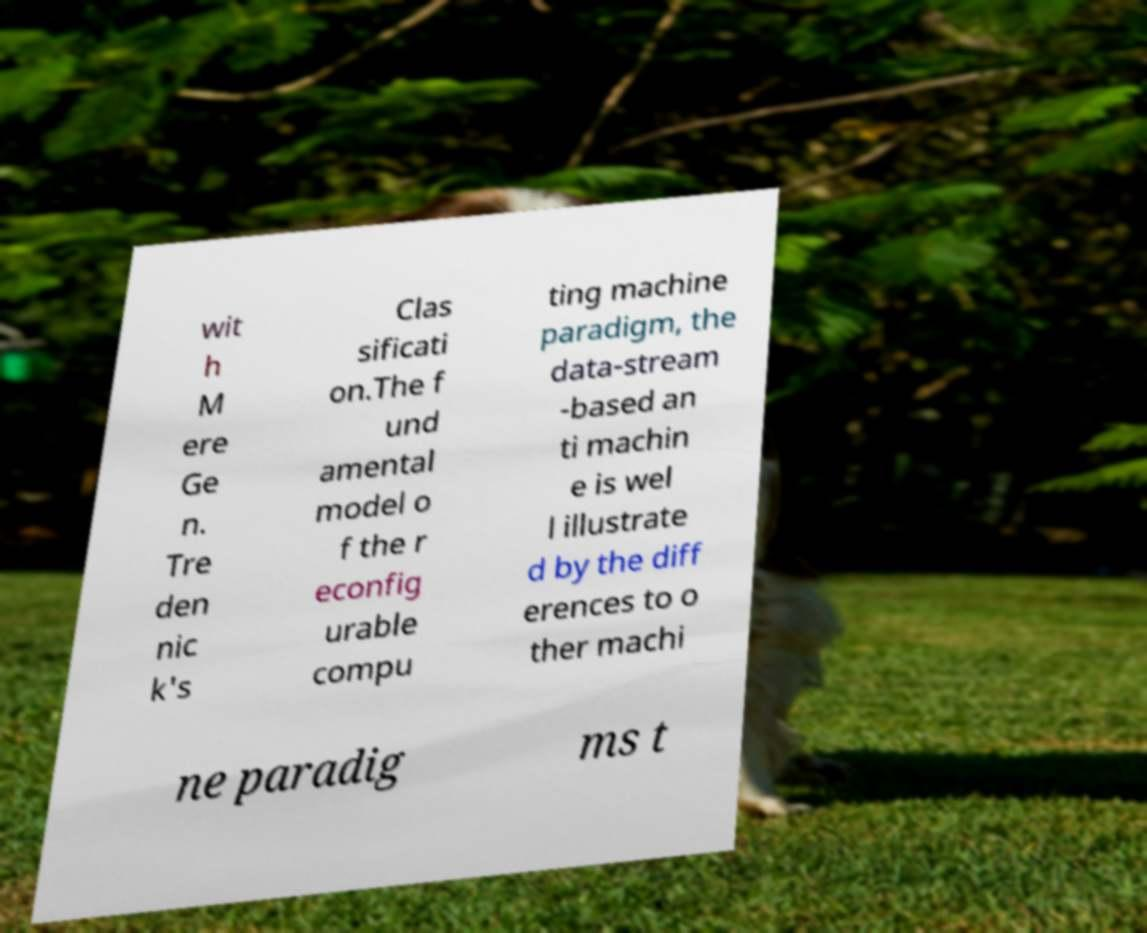Please read and relay the text visible in this image. What does it say? wit h M ere Ge n. Tre den nic k's Clas sificati on.The f und amental model o f the r econfig urable compu ting machine paradigm, the data-stream -based an ti machin e is wel l illustrate d by the diff erences to o ther machi ne paradig ms t 